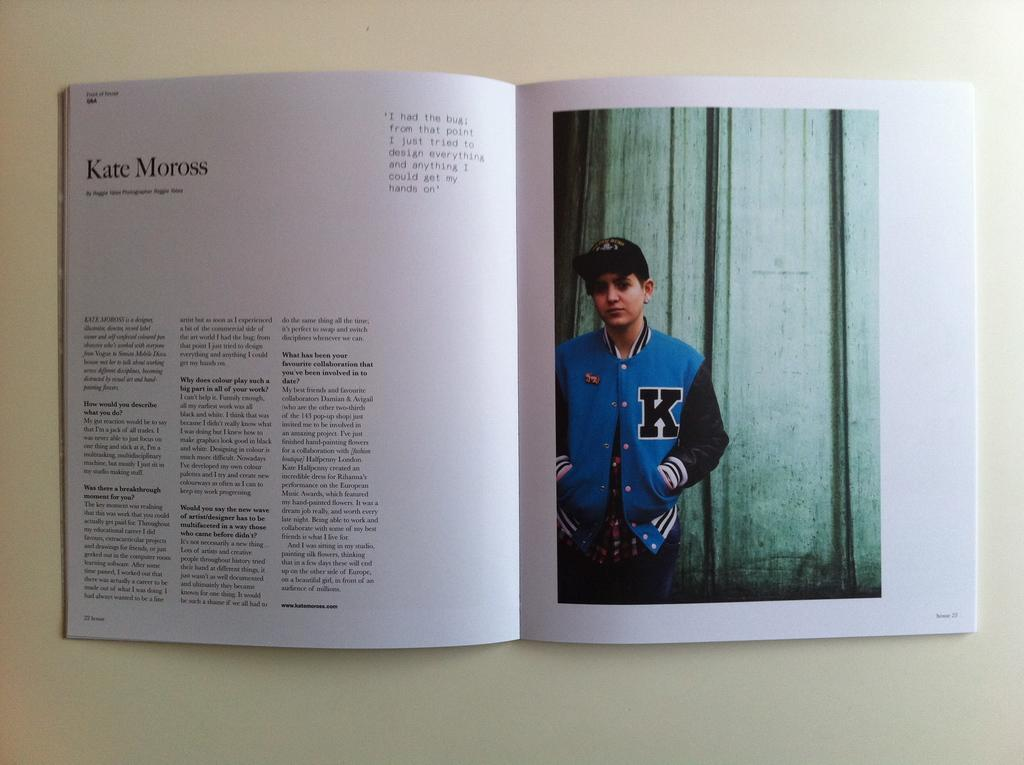Provide a one-sentence caption for the provided image. A magazine is open to a spread, the title Kate Moross and copy on the left and a image of a boy on the right page. 